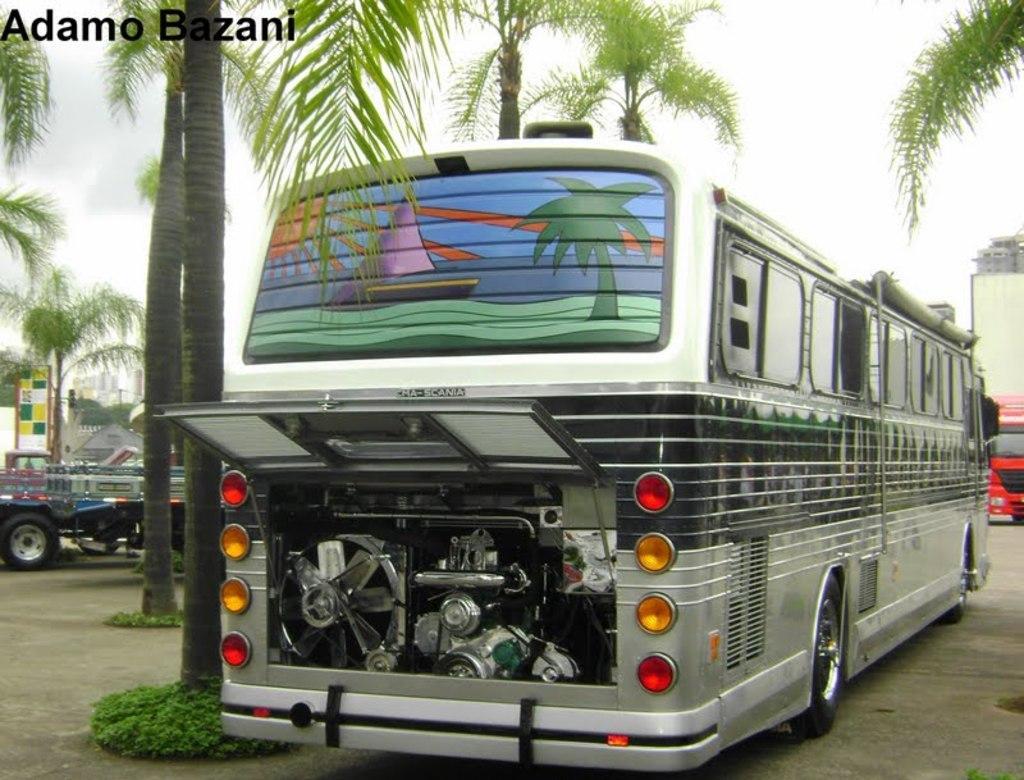Describe this image in one or two sentences. This image consists of bus in silver color. In the background, there is an engine. At the bottom, there is a road. To the left, there are coconut trees. To the right, there is a red color bus. At the top, there is a sky. 